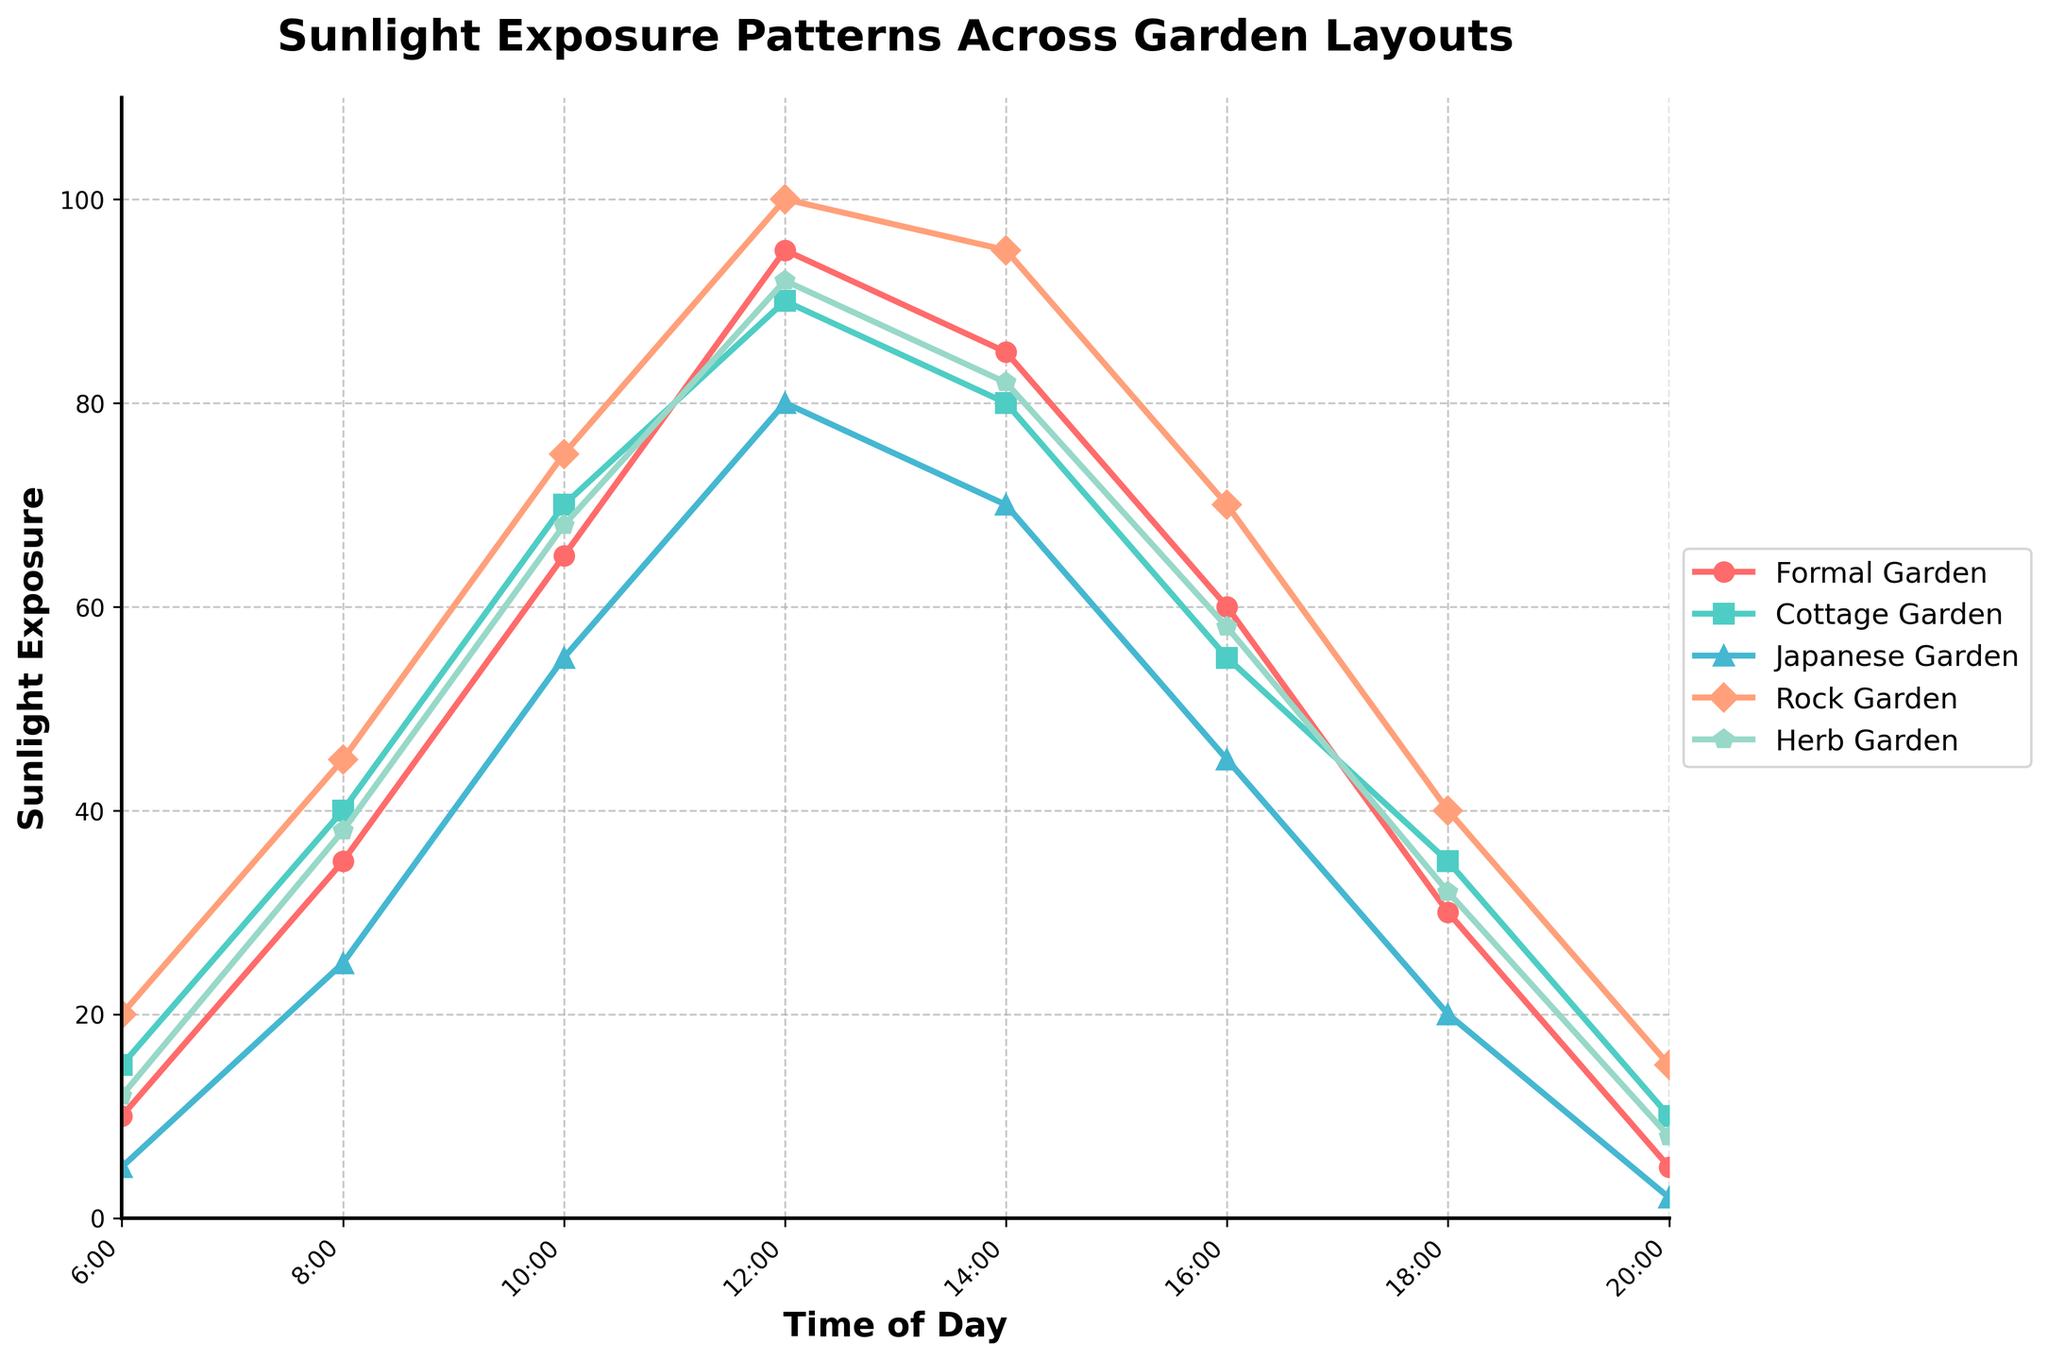What time of day does each garden layout receive the most sunlight exposure? From the line chart, we can observe the peak value for each garden layout. Formal Garden peaks at 12:00 (95), Cottage Garden peaks at 12:00 (90), Japanese Garden peaks at 12:00 (80), Rock Garden peaks at 12:00 (100), and Herb Garden peaks at 12:00 (92).
Answer: 12:00 Which garden layout receives the least sunlight exposure at 8:00 AM? From the line chart, at 8:00 AM, the Japanese Garden has the lowest sunlight exposure with a value of 25.
Answer: Japanese Garden Comparing sunlight exposure patterns, which garden layout has the most consistent decrease after reaching its peak? Rock Garden has a gradual and consistent decrease after reaching its peak at 12:00 with 100, falling to 15 by 20:00.
Answer: Rock Garden At what time does the Herb Garden receive more sunlight than the Formal Garden? Provide the time(s). By comparing the lines for the Herb Garden and Formal Garden, we see that the Herb Garden receives more sunlight than the Formal Garden only at 8:00 (38 vs 35) and at 14:00 (82 vs 85) but never surpasses it.
Answer: 8:00 What is the difference in sunlight exposure between the Japanese Garden and Rock Garden at 16:00? At 16:00, the sunlight exposure for the Japanese Garden is 45, and for the Rock Garden, it is 70. The difference is 70 - 45.
Answer: 25 Which garden layout has the highest sunlight exposure at 18:00, and what is that value? At 18:00, the Rock Garden has the highest sunlight exposure with a value of 40 as compared to other gardens.
Answer: Rock Garden, 40 Calculate the average sunlight exposure for Formal Garden throughout the day. Sum of all values for Formal Garden (10 + 35 + 65 + 95 + 85 + 60 + 30 + 5) is 385. There are 8 time points, so average is 385/8.
Answer: 48.125 How does the color used for the Cottage Garden line help in distinguishing it from others? The line for Cottage Garden is colored green, which contrasts with the other lines' colors (red for Formal, blue for Japanese, orange for Rock, and cyan for Herb), making it easily distinguishable.
Answer: Green What is the trend of sunlight exposure for the Japanese Garden from 14:00 to 20:00? From 14:00 to 16:00, sunlight exposure decreases from 70 to 45, from 16:00 to 18:00 it decreases further to 20, and from 18:00 to 20:00 it reaches 2. Overall, it's a declining trend.
Answer: Declining How much more sunlight does the Cottage Garden receive than the Japanese Garden at 10:00? At 10:00, the difference in sunlight exposure between the Cottage Garden (70) and Japanese Garden (55) is calculated as 70 - 55.
Answer: 15 